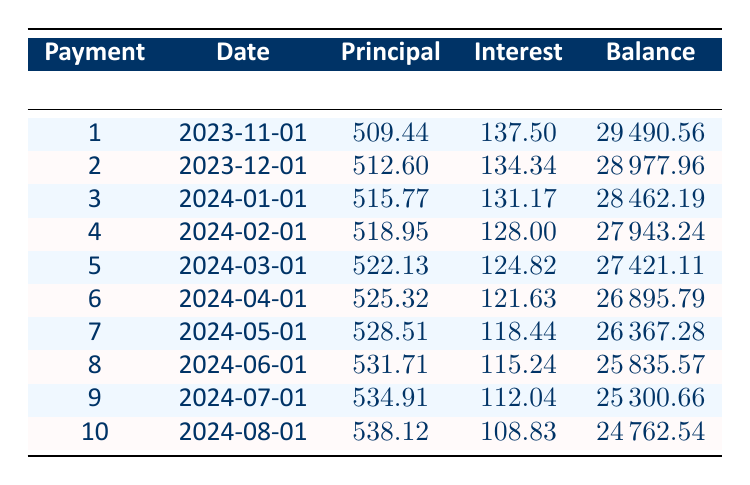What is the total loan amount for the vehicle? The total loan amount is specified directly in the data provided. It states that the loan amount is 30000.
Answer: 30000 How much is the monthly payment for the vehicle loan? The monthly payment is directly indicated in the data as 573.44.
Answer: 573.44 What is the balance remaining after the first payment? The balance after the first payment can be found in the table under the "Balance" column for payment number 1, which shows 29490.56.
Answer: 29490.56 What is the total interest paid over the term of the loan? The total interest paid is specified in the data and is 4407.15. This is a direct retrieval from the provided information.
Answer: 4407.15 Is the monthly interest for the first payment greater than 130? The monthly interest for the first payment is 137.50, which is indeed greater than 130. Therefore, this statement is true.
Answer: Yes What is the average principal payment made in the first five months? To find the average principal payment, sum the principal amounts for the first five payments: 509.44 + 512.60 + 515.77 + 518.95 + 522.13 = 2578.89. Then divide by 5: 2578.89 / 5 = 515.78.
Answer: 515.78 How much principal was paid in the third month compared to the first month? The principal for the third month is 515.77 and for the first month it is 509.44. The difference is calculated as 515.77 - 509.44 = 6.33. Therefore, more principal was paid in the third month.
Answer: 6.33 What is the total interest paid in the first two months? The interest paid in the first two months can be calculated by adding the interest amounts for each of these months: 137.50 + 134.34 = 271.84. Thus, the total interest paid is 271.84.
Answer: 271.84 How many months is the loan term? The loan term is specified in the data as 5 years, which corresponds to 60 months (5 years x 12 months/year = 60 months).
Answer: 60 months What is the remaining balance after the fifth payment? To find the remaining balance after the fifth payment, refer to the balance column and the value after the fifth payment, which is 27421.11.
Answer: 27421.11 